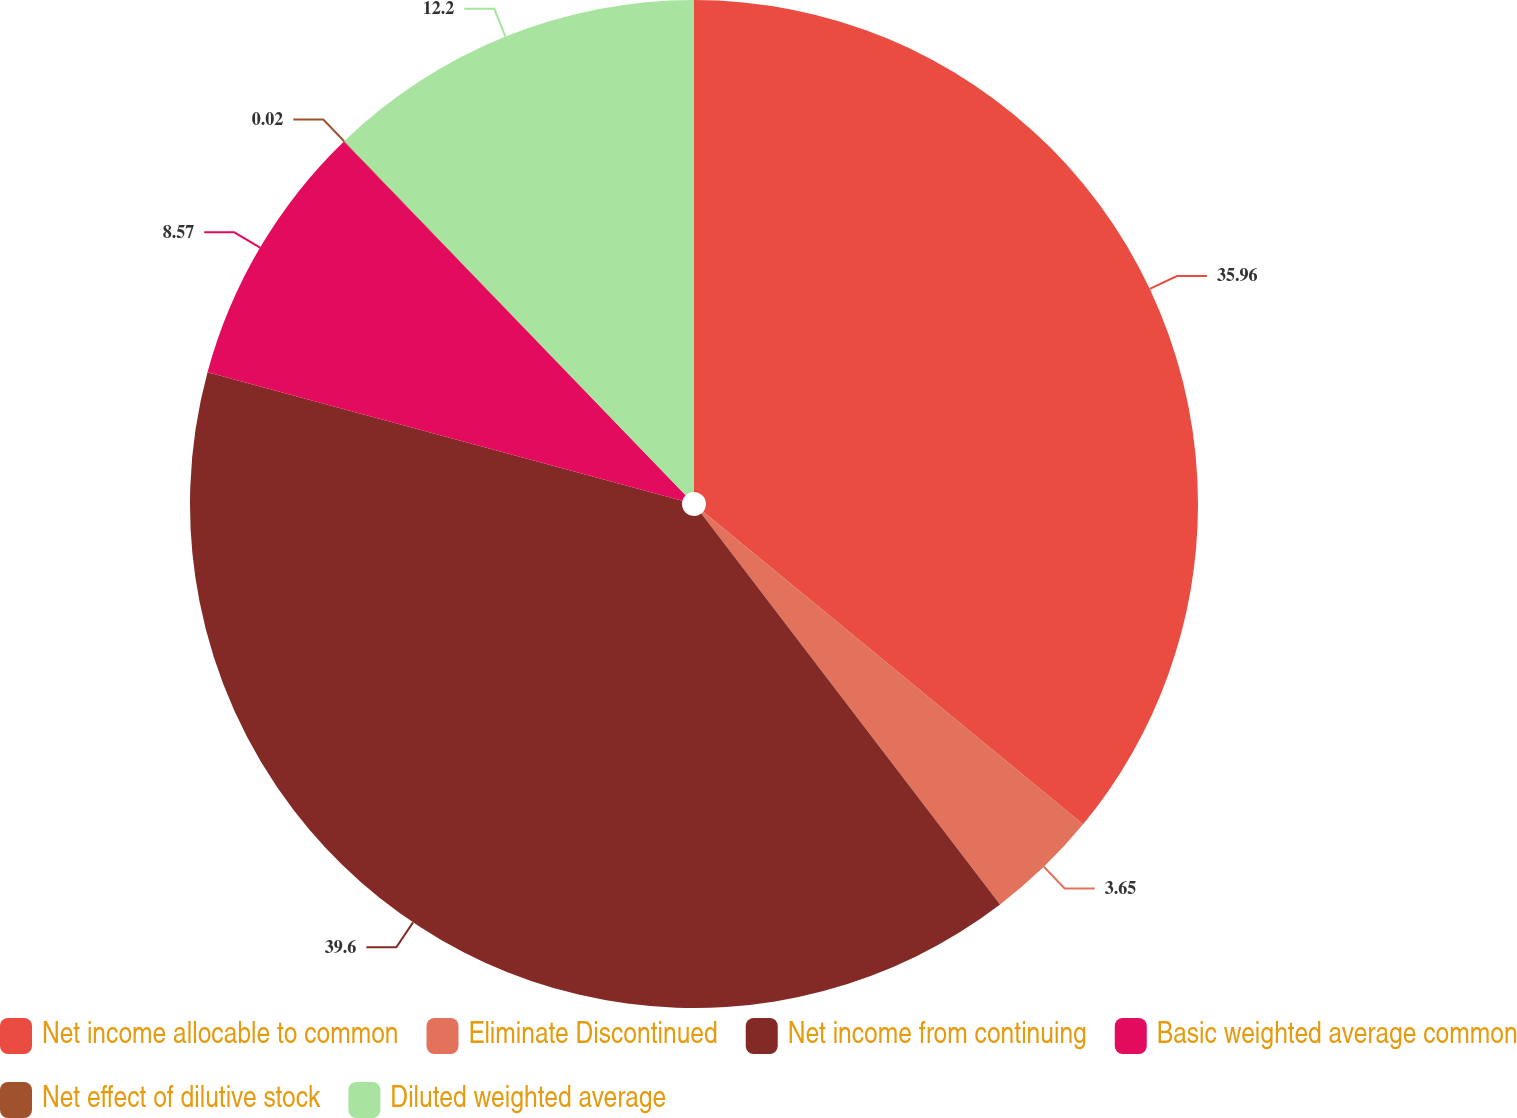<chart> <loc_0><loc_0><loc_500><loc_500><pie_chart><fcel>Net income allocable to common<fcel>Eliminate Discontinued<fcel>Net income from continuing<fcel>Basic weighted average common<fcel>Net effect of dilutive stock<fcel>Diluted weighted average<nl><fcel>35.96%<fcel>3.65%<fcel>39.59%<fcel>8.57%<fcel>0.02%<fcel>12.2%<nl></chart> 